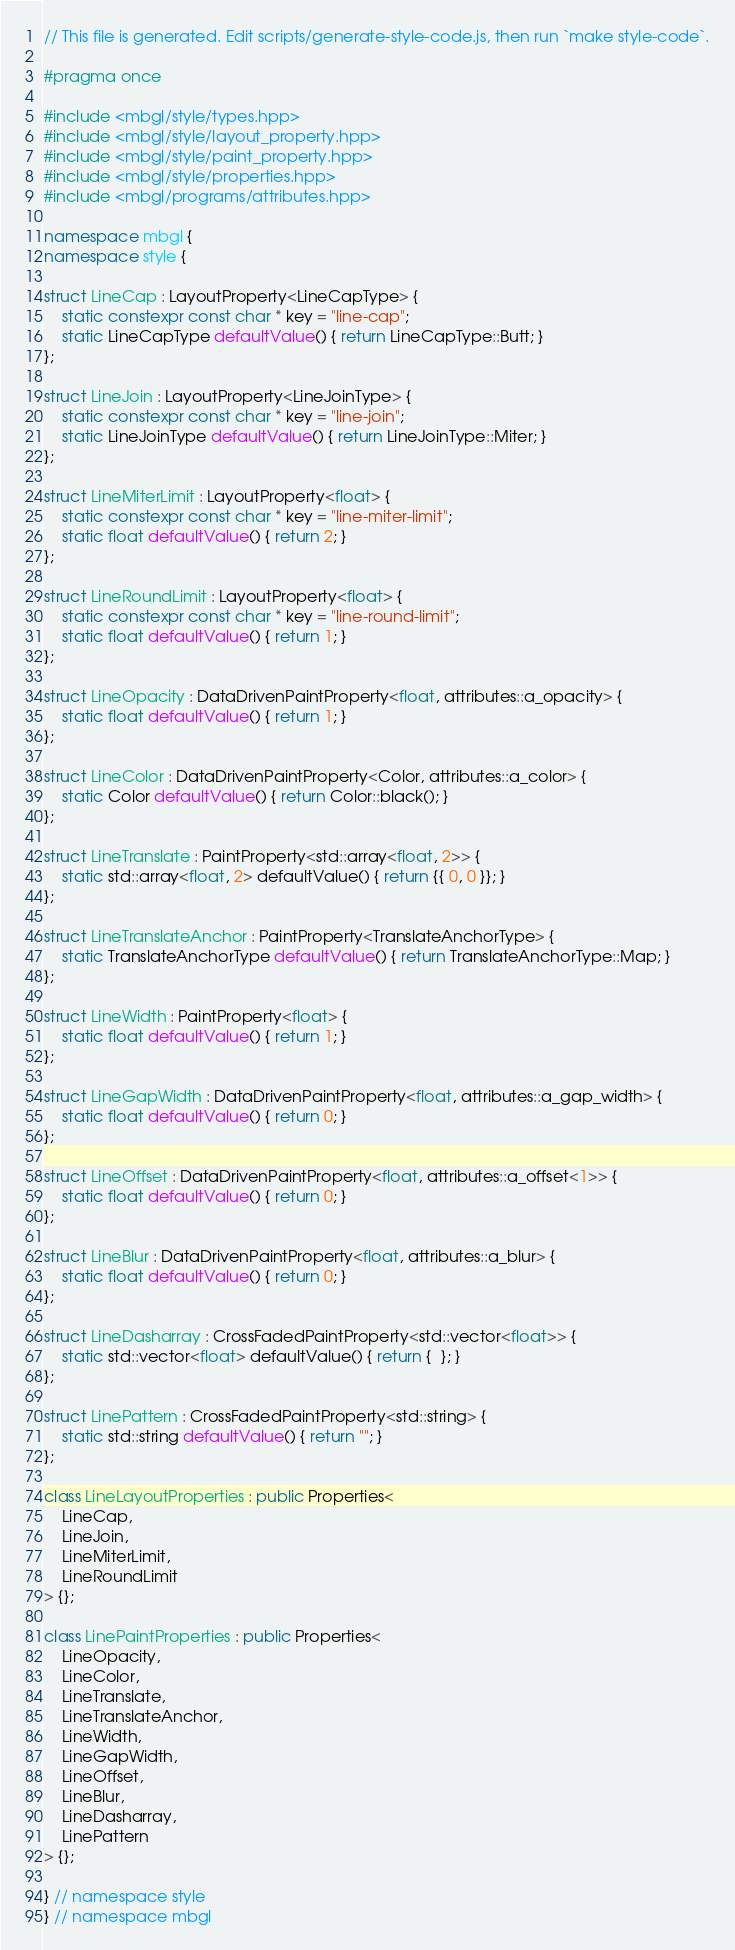Convert code to text. <code><loc_0><loc_0><loc_500><loc_500><_C++_>// This file is generated. Edit scripts/generate-style-code.js, then run `make style-code`.

#pragma once

#include <mbgl/style/types.hpp>
#include <mbgl/style/layout_property.hpp>
#include <mbgl/style/paint_property.hpp>
#include <mbgl/style/properties.hpp>
#include <mbgl/programs/attributes.hpp>

namespace mbgl {
namespace style {

struct LineCap : LayoutProperty<LineCapType> {
    static constexpr const char * key = "line-cap";
    static LineCapType defaultValue() { return LineCapType::Butt; }
};

struct LineJoin : LayoutProperty<LineJoinType> {
    static constexpr const char * key = "line-join";
    static LineJoinType defaultValue() { return LineJoinType::Miter; }
};

struct LineMiterLimit : LayoutProperty<float> {
    static constexpr const char * key = "line-miter-limit";
    static float defaultValue() { return 2; }
};

struct LineRoundLimit : LayoutProperty<float> {
    static constexpr const char * key = "line-round-limit";
    static float defaultValue() { return 1; }
};

struct LineOpacity : DataDrivenPaintProperty<float, attributes::a_opacity> {
    static float defaultValue() { return 1; }
};

struct LineColor : DataDrivenPaintProperty<Color, attributes::a_color> {
    static Color defaultValue() { return Color::black(); }
};

struct LineTranslate : PaintProperty<std::array<float, 2>> {
    static std::array<float, 2> defaultValue() { return {{ 0, 0 }}; }
};

struct LineTranslateAnchor : PaintProperty<TranslateAnchorType> {
    static TranslateAnchorType defaultValue() { return TranslateAnchorType::Map; }
};

struct LineWidth : PaintProperty<float> {
    static float defaultValue() { return 1; }
};

struct LineGapWidth : DataDrivenPaintProperty<float, attributes::a_gap_width> {
    static float defaultValue() { return 0; }
};

struct LineOffset : DataDrivenPaintProperty<float, attributes::a_offset<1>> {
    static float defaultValue() { return 0; }
};

struct LineBlur : DataDrivenPaintProperty<float, attributes::a_blur> {
    static float defaultValue() { return 0; }
};

struct LineDasharray : CrossFadedPaintProperty<std::vector<float>> {
    static std::vector<float> defaultValue() { return {  }; }
};

struct LinePattern : CrossFadedPaintProperty<std::string> {
    static std::string defaultValue() { return ""; }
};

class LineLayoutProperties : public Properties<
    LineCap,
    LineJoin,
    LineMiterLimit,
    LineRoundLimit
> {};

class LinePaintProperties : public Properties<
    LineOpacity,
    LineColor,
    LineTranslate,
    LineTranslateAnchor,
    LineWidth,
    LineGapWidth,
    LineOffset,
    LineBlur,
    LineDasharray,
    LinePattern
> {};

} // namespace style
} // namespace mbgl
</code> 